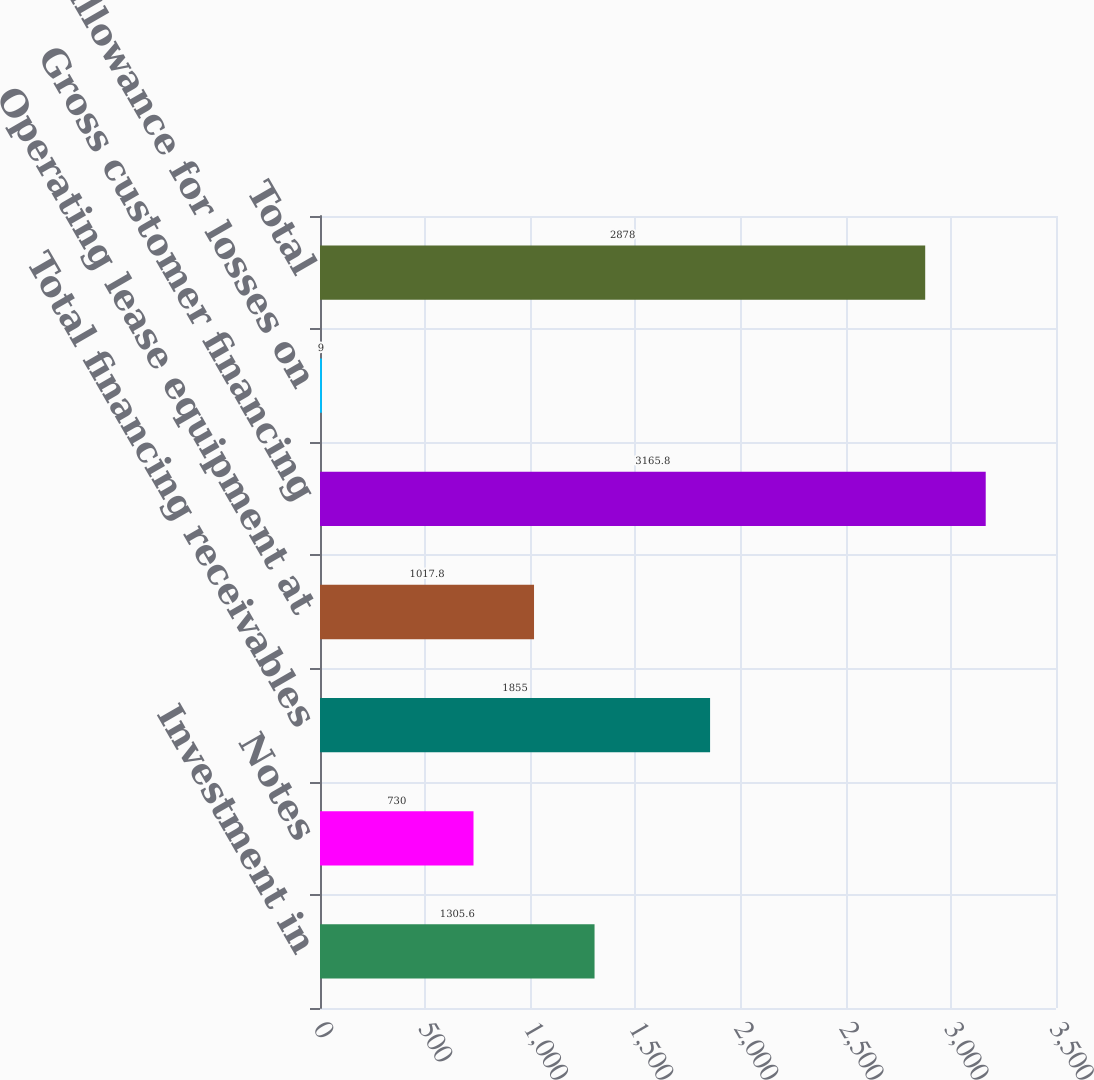<chart> <loc_0><loc_0><loc_500><loc_500><bar_chart><fcel>Investment in<fcel>Notes<fcel>Total financing receivables<fcel>Operating lease equipment at<fcel>Gross customer financing<fcel>Less allowance for losses on<fcel>Total<nl><fcel>1305.6<fcel>730<fcel>1855<fcel>1017.8<fcel>3165.8<fcel>9<fcel>2878<nl></chart> 